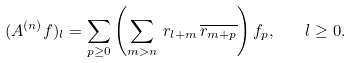<formula> <loc_0><loc_0><loc_500><loc_500>( A ^ { ( n ) } f ) _ { l } = \sum _ { p \geq 0 } \left ( \sum _ { m > n } \, r _ { l + m } \, \overline { r _ { m + p } } \right ) f _ { p } , \quad l \geq 0 .</formula> 